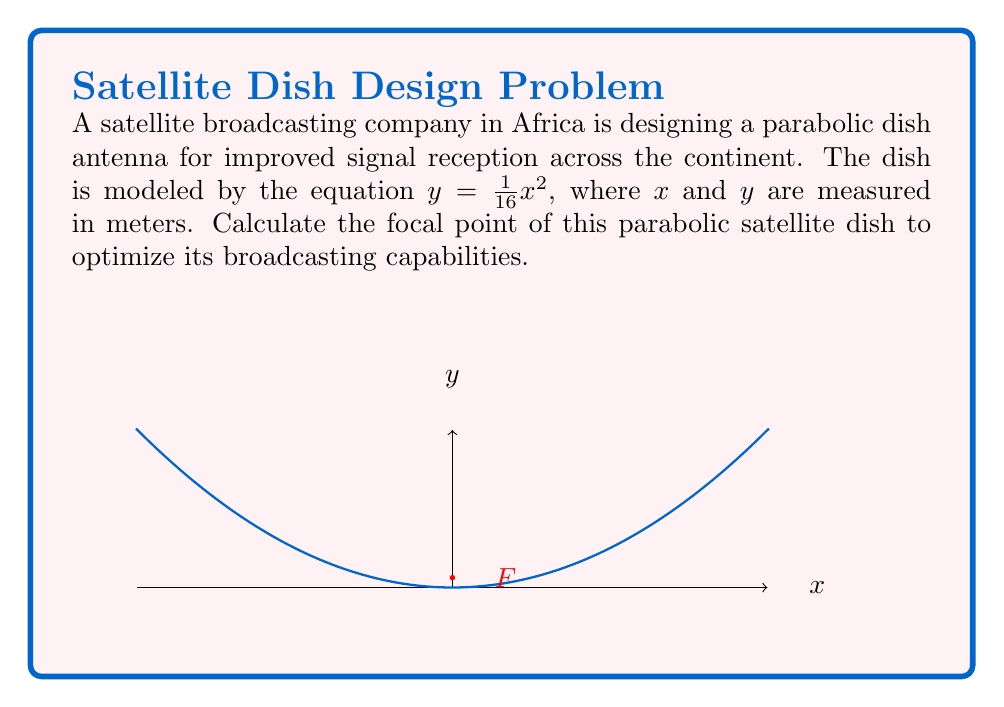Help me with this question. To find the focal points of a parabolic dish, we need to follow these steps:

1) The general equation of a parabola with vertex at the origin is:

   $y = \frac{1}{4p}x^2$

   where $p$ is the distance from the vertex to the focus.

2) In our case, the equation is $y = \frac{1}{16}x^2$

3) Comparing these equations, we can see that:

   $\frac{1}{4p} = \frac{1}{16}$

4) Solving for $p$:

   $p = \frac{16}{4} = 4$

5) The focal length of a parabola is equal to $p$. Therefore, the focal length is 4 meters.

6) For a parabola with its vertex at the origin and axis of symmetry along the y-axis, the focus is located at (0, p).

7) Therefore, the focus of this parabolic dish is at (0, 4) meters.

8) Since the parabola opens upward, there is only one focal point.

This focal point is crucial for the dish's signal reception and transmission capabilities, as all signals parallel to the axis of the parabola will be reflected to this point, maximizing the efficiency of the broadcasting system across the African continent.
Answer: (0, 4) meters 